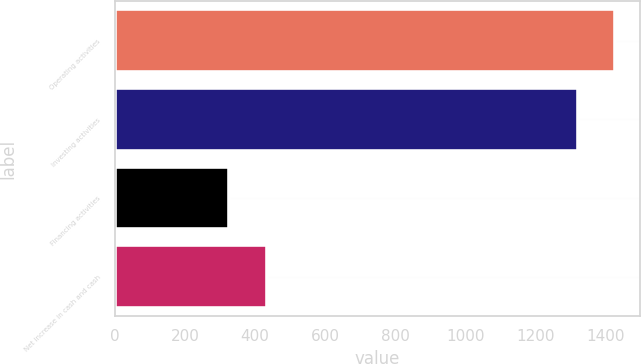<chart> <loc_0><loc_0><loc_500><loc_500><bar_chart><fcel>Operating activities<fcel>Investing activities<fcel>Financing activities<fcel>Net increase in cash and cash<nl><fcel>1428.3<fcel>1321<fcel>326<fcel>433.3<nl></chart> 